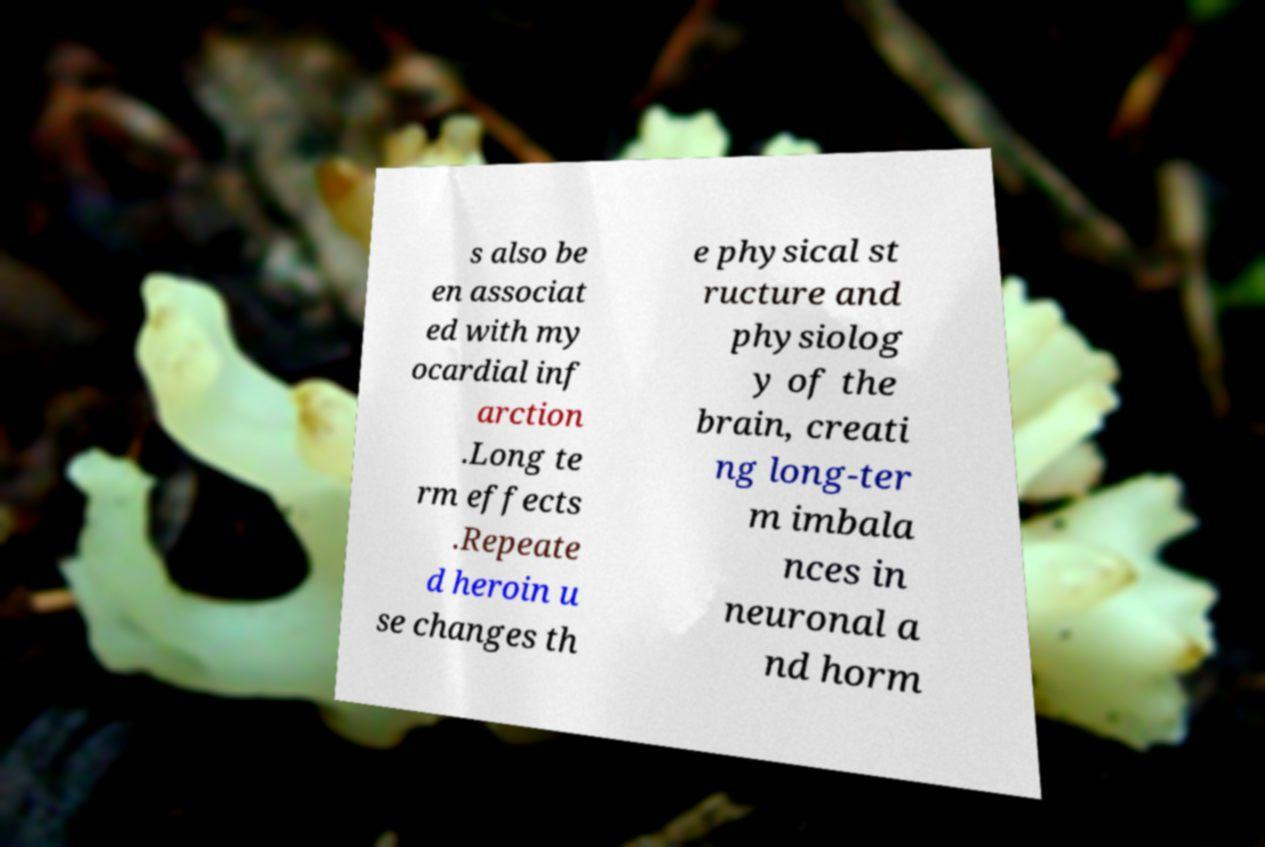For documentation purposes, I need the text within this image transcribed. Could you provide that? s also be en associat ed with my ocardial inf arction .Long te rm effects .Repeate d heroin u se changes th e physical st ructure and physiolog y of the brain, creati ng long-ter m imbala nces in neuronal a nd horm 